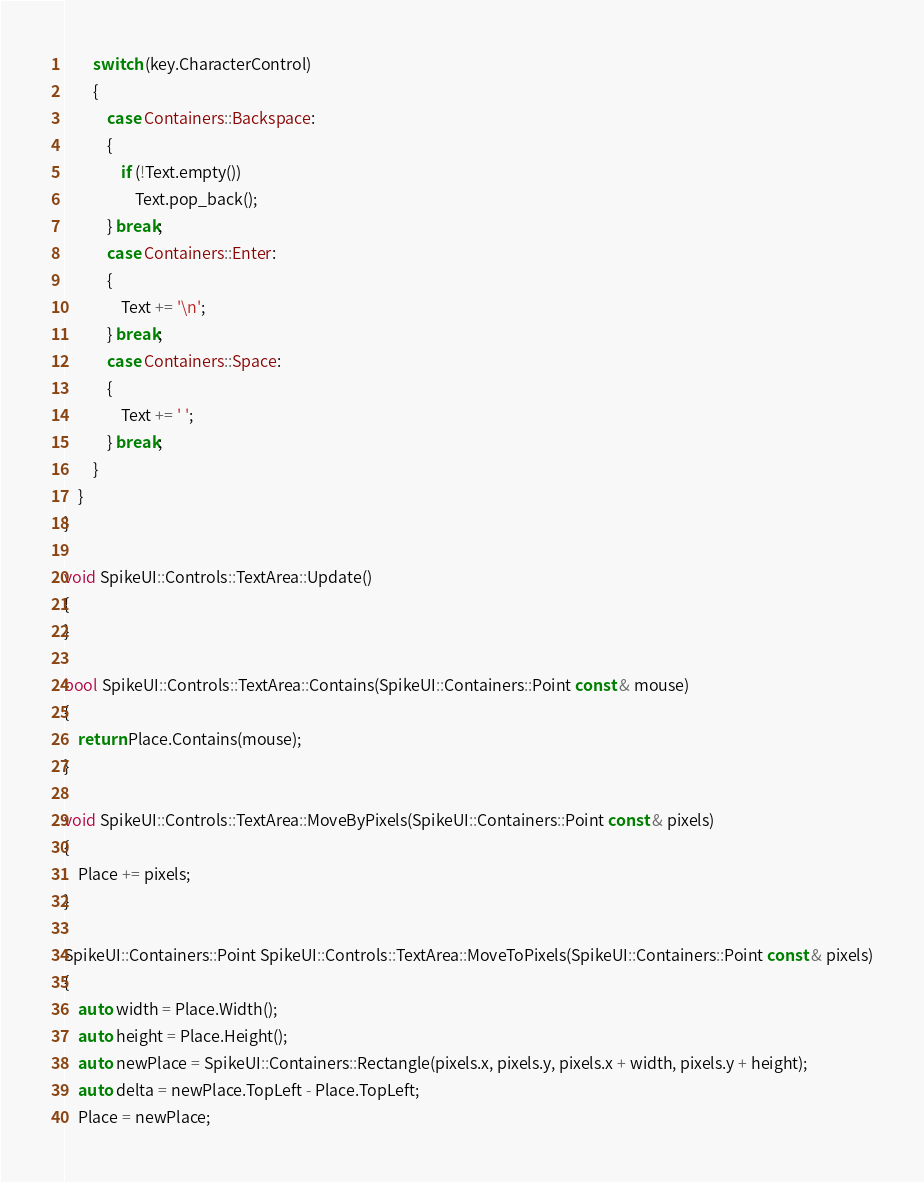<code> <loc_0><loc_0><loc_500><loc_500><_C++_>		switch (key.CharacterControl)
		{
			case Containers::Backspace:
			{
				if (!Text.empty())
					Text.pop_back();
			} break;
			case Containers::Enter:
			{
				Text += '\n';
			} break;
			case Containers::Space:
			{
				Text += ' ';
			} break;
		}
	}
}

void SpikeUI::Controls::TextArea::Update()
{
}

bool SpikeUI::Controls::TextArea::Contains(SpikeUI::Containers::Point const & mouse)
{
	return Place.Contains(mouse);
}

void SpikeUI::Controls::TextArea::MoveByPixels(SpikeUI::Containers::Point const & pixels)
{
	Place += pixels;
}

SpikeUI::Containers::Point SpikeUI::Controls::TextArea::MoveToPixels(SpikeUI::Containers::Point const & pixels)
{
	auto width = Place.Width();
	auto height = Place.Height();
	auto newPlace = SpikeUI::Containers::Rectangle(pixels.x, pixels.y, pixels.x + width, pixels.y + height);
	auto delta = newPlace.TopLeft - Place.TopLeft;
	Place = newPlace;</code> 